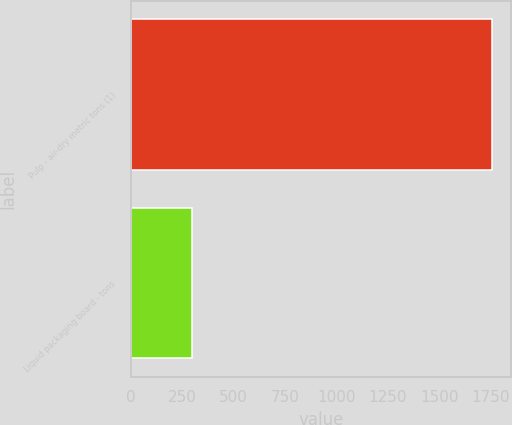Convert chart. <chart><loc_0><loc_0><loc_500><loc_500><bar_chart><fcel>Pulp - air-dry metric tons (1)<fcel>Liquid packaging board - tons<nl><fcel>1760<fcel>297<nl></chart> 